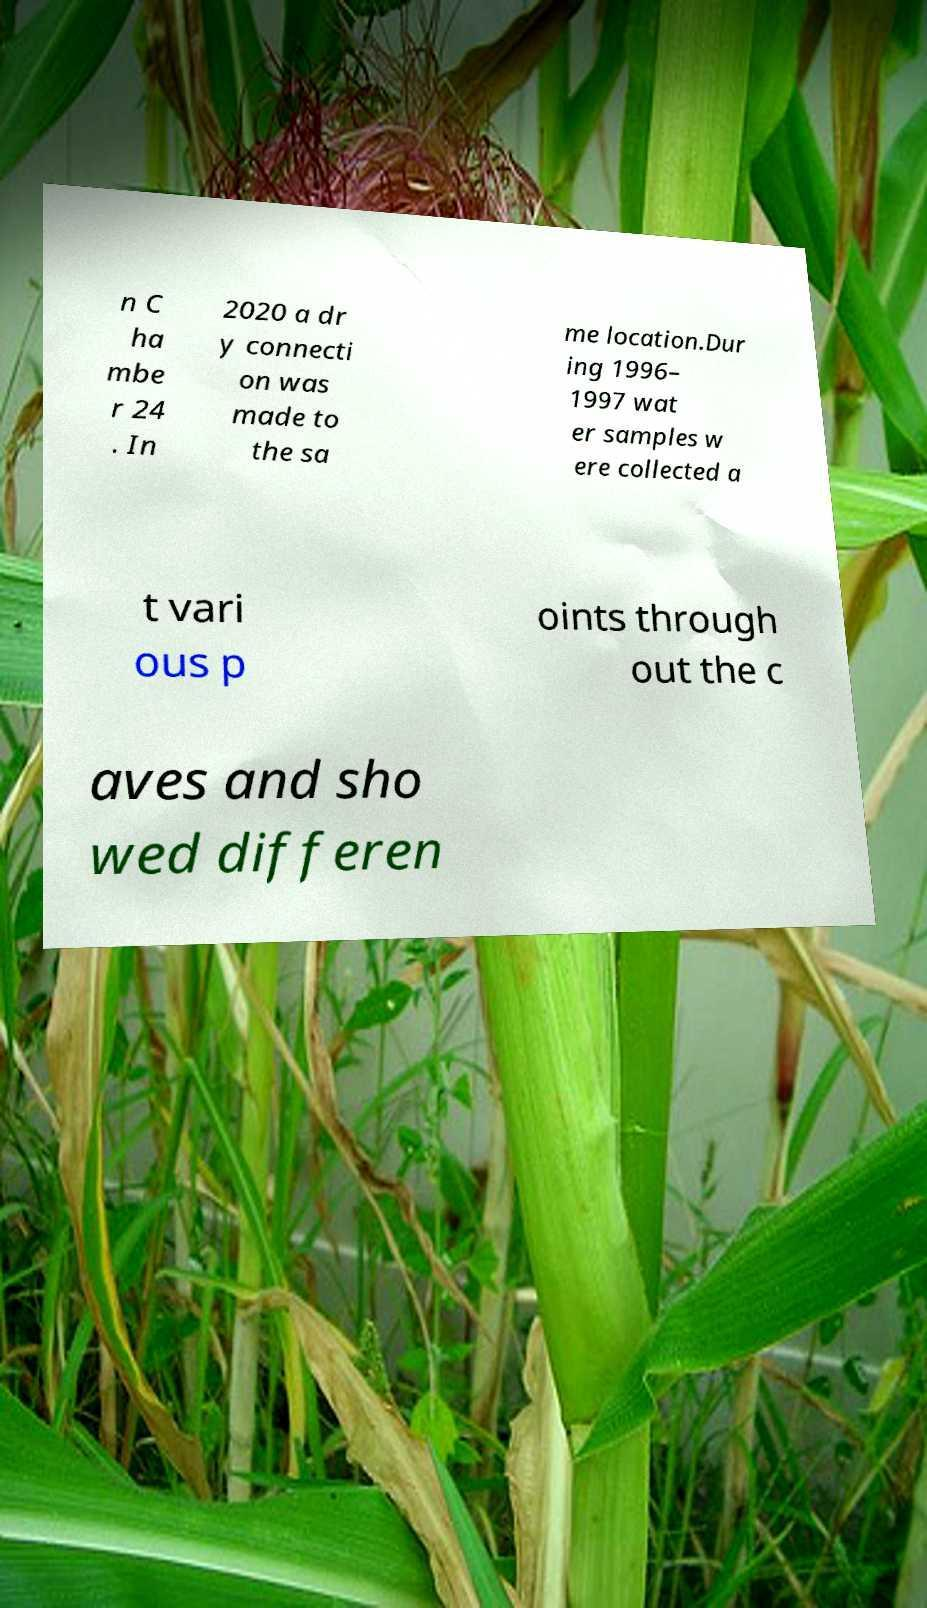Could you assist in decoding the text presented in this image and type it out clearly? n C ha mbe r 24 . In 2020 a dr y connecti on was made to the sa me location.Dur ing 1996– 1997 wat er samples w ere collected a t vari ous p oints through out the c aves and sho wed differen 